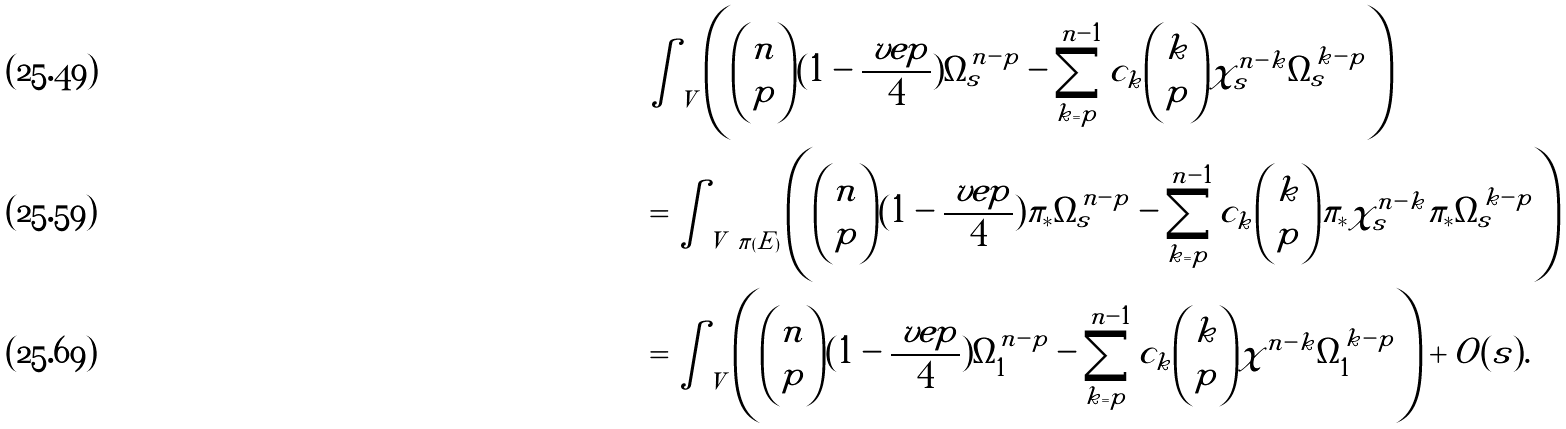<formula> <loc_0><loc_0><loc_500><loc_500>& \int _ { \tilde { V } } \left ( { n \choose p } ( 1 - \frac { \ v e p } { 4 } ) \tilde { \Omega } _ { s } ^ { n - p } - \sum _ { k = p } ^ { n - 1 } c _ { k } { k \choose p } \tilde { \chi } _ { s } ^ { n - k } \tilde { \Omega } _ { s } ^ { k - p } \right ) \\ & = \int _ { V \ \pi ( \tilde { E } ) } \left ( { n \choose p } ( 1 - \frac { \ v e p } { 4 } ) \pi _ { * } \tilde { \Omega } _ { s } ^ { n - p } - \sum _ { k = p } ^ { n - 1 } c _ { k } { k \choose p } \pi _ { * } \tilde { \chi } _ { s } ^ { n - k } \pi _ { * } \tilde { \Omega } _ { s } ^ { k - p } \right ) \\ & = \int _ { V } \left ( { n \choose p } ( 1 - \frac { \ v e p } { 4 } ) \Omega _ { 1 } ^ { n - p } - \sum _ { k = p } ^ { n - 1 } c _ { k } { k \choose p } \chi ^ { n - k } \Omega _ { 1 } ^ { k - p } \right ) + O ( s ) . \</formula> 